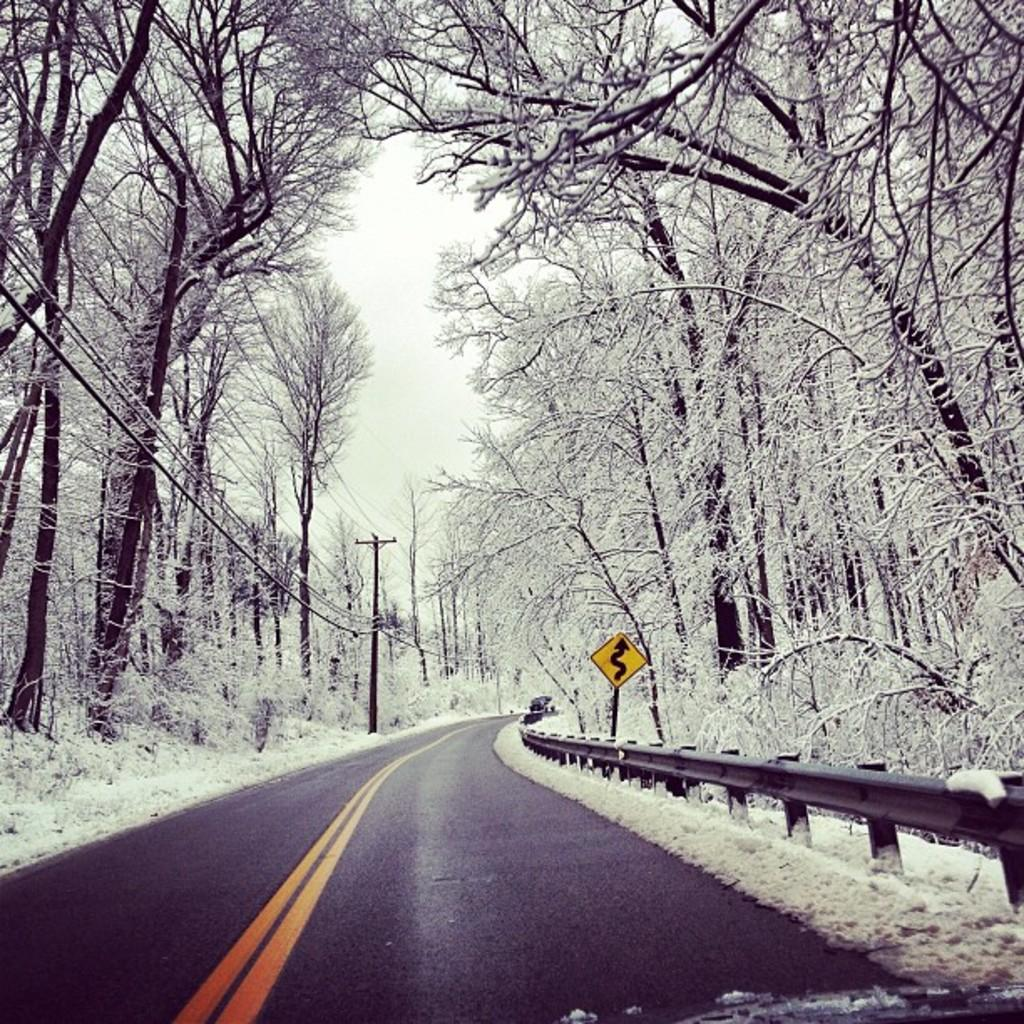What is on the road in the image? There is a vehicle on the road in the image. What is the weather like in the image? The presence of snow on both the right and left sides of the image suggests a snowy environment. What type of vegetation can be seen in the image? There are plants visible in the image. What can be seen in the background of the image? The sky is visible in the background of the image. What type of punishment is being given to the tramp in the image? There is no tramp or any indication of punishment present in the image. 